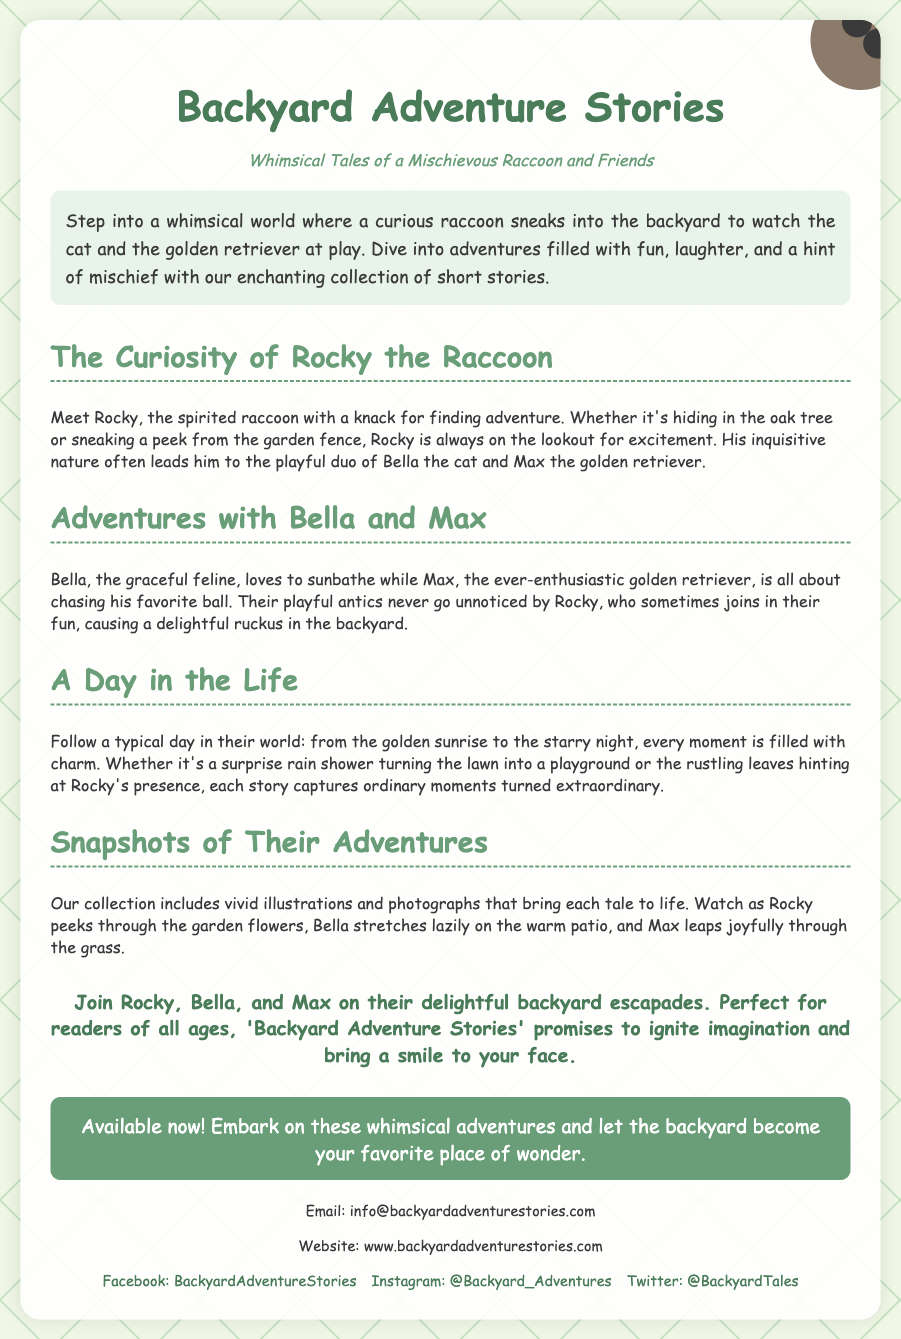What is the title of the collection? The title of the collection is the main heading in the document, which introduces the theme and content of the flyer.
Answer: Backyard Adventure Stories Who is the main character in the stories? The main character is introduced in the sections and is the focal point of the whimsical tales.
Answer: Rocky the Raccoon What animal is Bella in the stories? Bella is mentioned as one of the main characters, specifically categorized into a specific kind of animal.
Answer: Cat What is Max's role in the stories? Max is described as an enthusiastic character known for his playful behavior, providing insight into his character type.
Answer: Golden Retriever How many sections are in the flyer? By counting the distinct sections that provide different aspects of the stories, we can determine the total number.
Answer: Four What type of experiences do the stories feature? The stories capture specific types of moments and themes, reflecting the playful nature of the characters involved.
Answer: Whimsical adventures What color is the background of the flyer? The background color is specified in the styling section of the document, providing visual context.
Answer: Light green Is the book available now? The availability of the book is clearly stated in a call-to-action section, informing potential readers.
Answer: Yes What is the email address provided for contact? The email address is mentioned in the contact section, offering a way for readers to reach out.
Answer: info@backyardadventurestories.com 